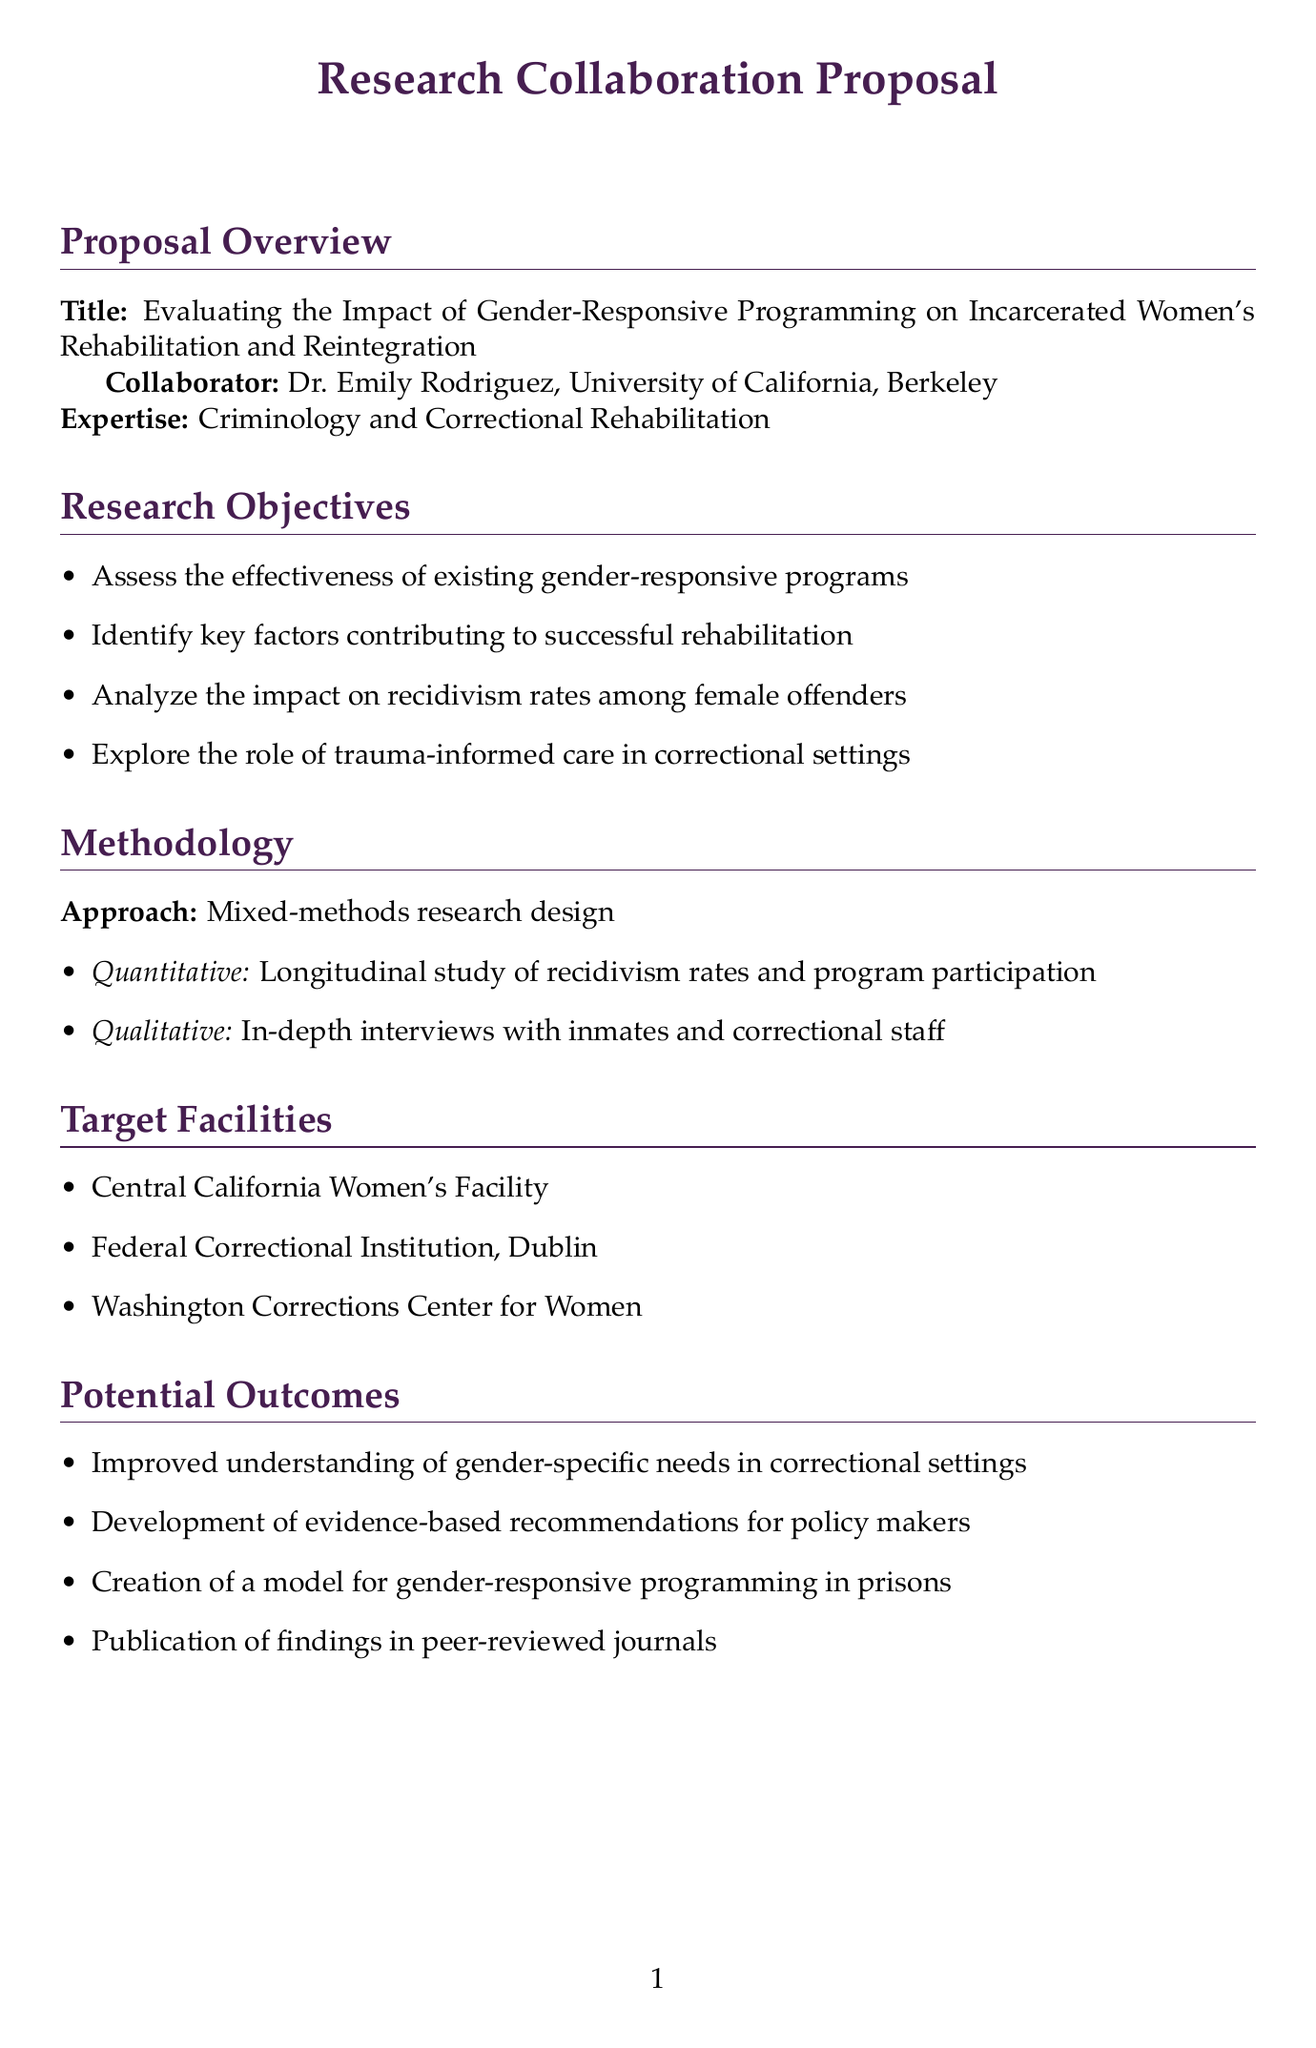What is the proposal title? The title of the proposal is stated at the beginning of the document.
Answer: Evaluating the Impact of Gender-Responsive Programming on Incarcerated Women's Rehabilitation and Reintegration Who is the collaborator's name? The collaborator's name is mentioned in the proposal overview section.
Answer: Dr. Emily Rodriguez What is the duration of the research project? The duration is specified in the timeline section of the document.
Answer: 36 months What methodology will be used in the research? The methodology is described in the methodology section, providing the research approach.
Answer: Mixed-methods research design Which institution is Dr. Emily Rodriguez affiliated with? The institution associated with Dr. Emily Rodriguez is listed in the proposal overview.
Answer: University of California, Berkeley What type of study is included in the quantitative component? This detail regarding the quantitative approach is provided in the methodology section.
Answer: Longitudinal study of recidivism rates and program participation What are one of the ethical considerations mentioned? Ethical considerations are outlined in a dedicated section of the document.
Answer: Ensuring informed consent from incarcerated participants What is one potential outcome of the research? Potential outcomes are enumerated in the potential outcomes section of the document.
Answer: Improved understanding of gender-specific needs in correctional settings What are the major milestones listed in the timeline? Major milestones are clearly outlined in the timeline section.
Answer: IRB approval and participant recruitment 